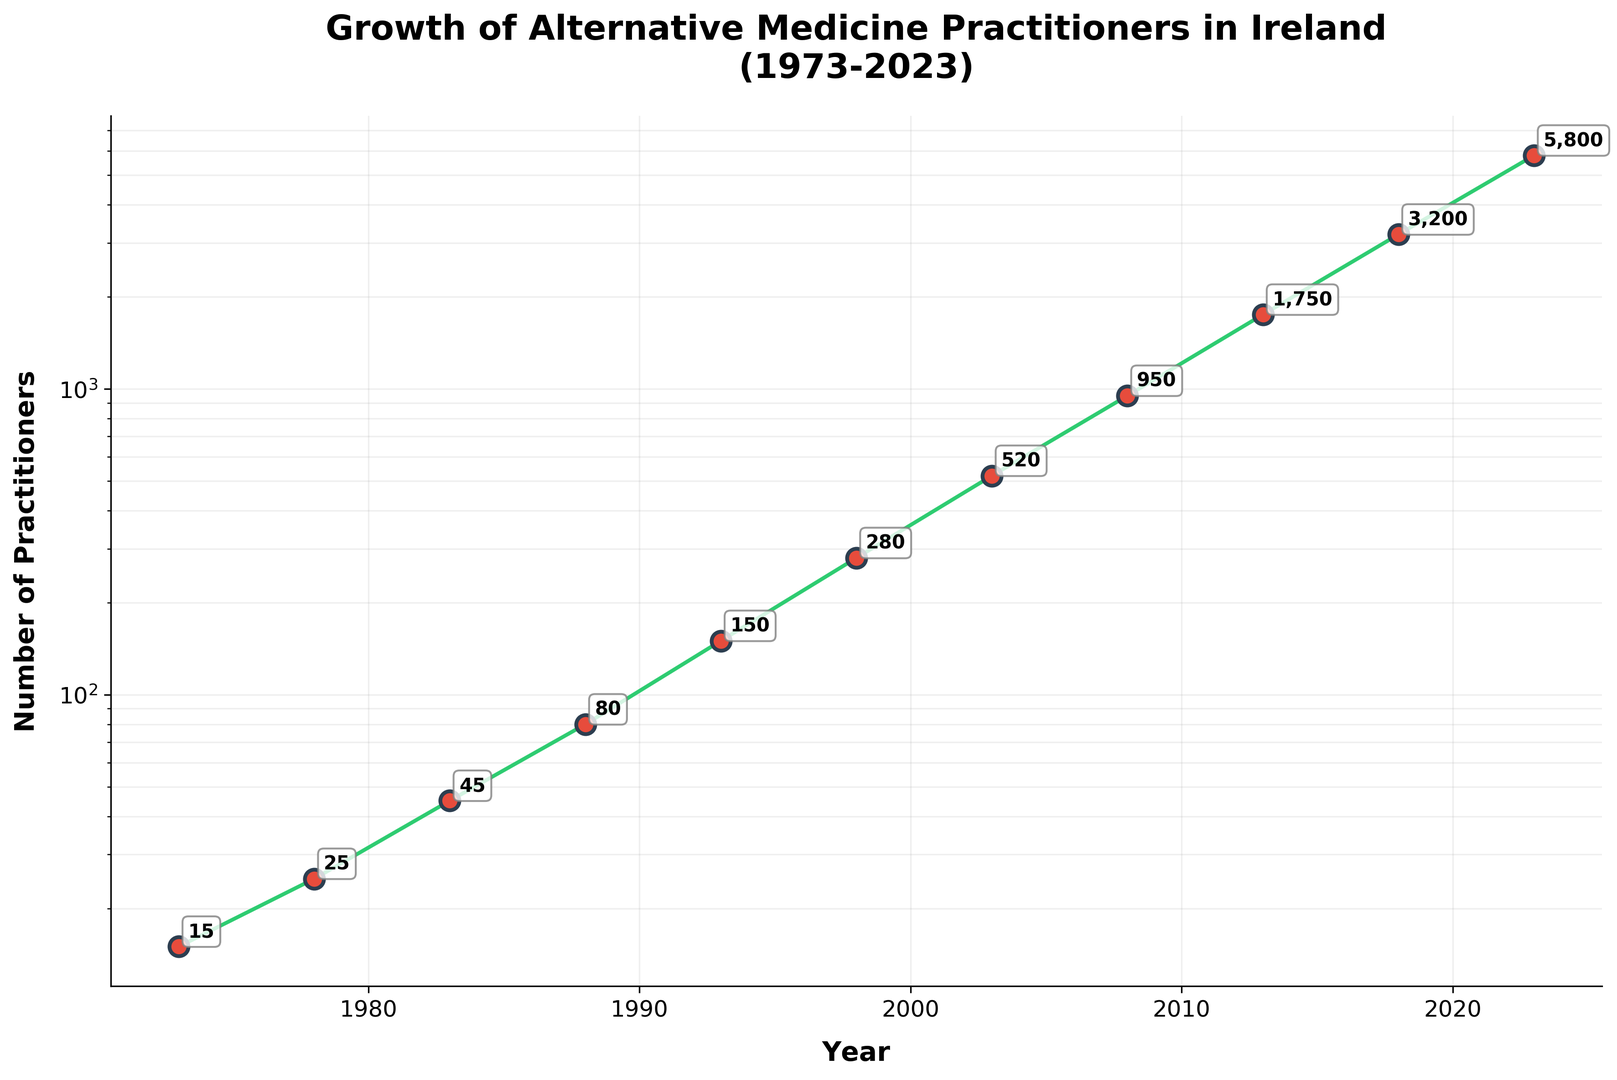Which year has the highest number of alternative medicine practitioners? The year with the highest number of practitioners is the data point with the highest y-value on the chart. In 2023, the number of practitioners is 5800, which is the highest number on the chart.
Answer: 2023 How many practitioners were there in 1993? Look at the annotation on the data point corresponding to the year 1993 on the chart. The number of practitioners in 1993 is 150.
Answer: 150 By how much did the number of practitioners increase from 1973 to 1988? The number of practitioners in 1973 was 15, and in 1988 it was 80. The difference between these values is 80 - 15 = 65.
Answer: 65 What is the average growth rate in the number of practitioners per year between 1983 and 1998? The number of practitioners in 1983 was 45, and in 1998 it was 280. The time span is 1998 - 1983 = 15 years. The increase in practitioners is 280 - 45 = 235. Divide the increase by the number of years to get the average growth rate: 235 / 15 = 15.67.
Answer: 15.67 practitioners per year Which period experienced the highest growth in practitioners? Examine the chart for the steepest increase. The period from 2003 to 2008 shows the highest growth. The number of practitioners went from 520 to 950.
Answer: 2003-2008 During which decade did the number of practitioners double? Look for a period where the value doubled approximately. In 1993, there were 150 practitioners, and in 2003, there were 520. The numbers more than doubled, with the clearest indicator between 1998 (280) and 2003 (520), even though it slightly more than doubled.
Answer: 1998-2003 What visual cue indicates an exponential growth in the number of practitioners? On a logscale chart, exponential growth appears as a straight line with a positive slope. The line on the chart is straight, showing exponential growth.
Answer: Straight line on logscale By how much did the number of practitioners increase from 2013 to 2023? The number of practitioners in 2013 was 1750, and in 2023 it was 5800. The difference is 5800 - 1750 = 4050.
Answer: 4050 How many practitioners were there in 2008? Look at the annotation for the year 2008 on the chart. The number of practitioners in 2008 is 950.
Answer: 950 